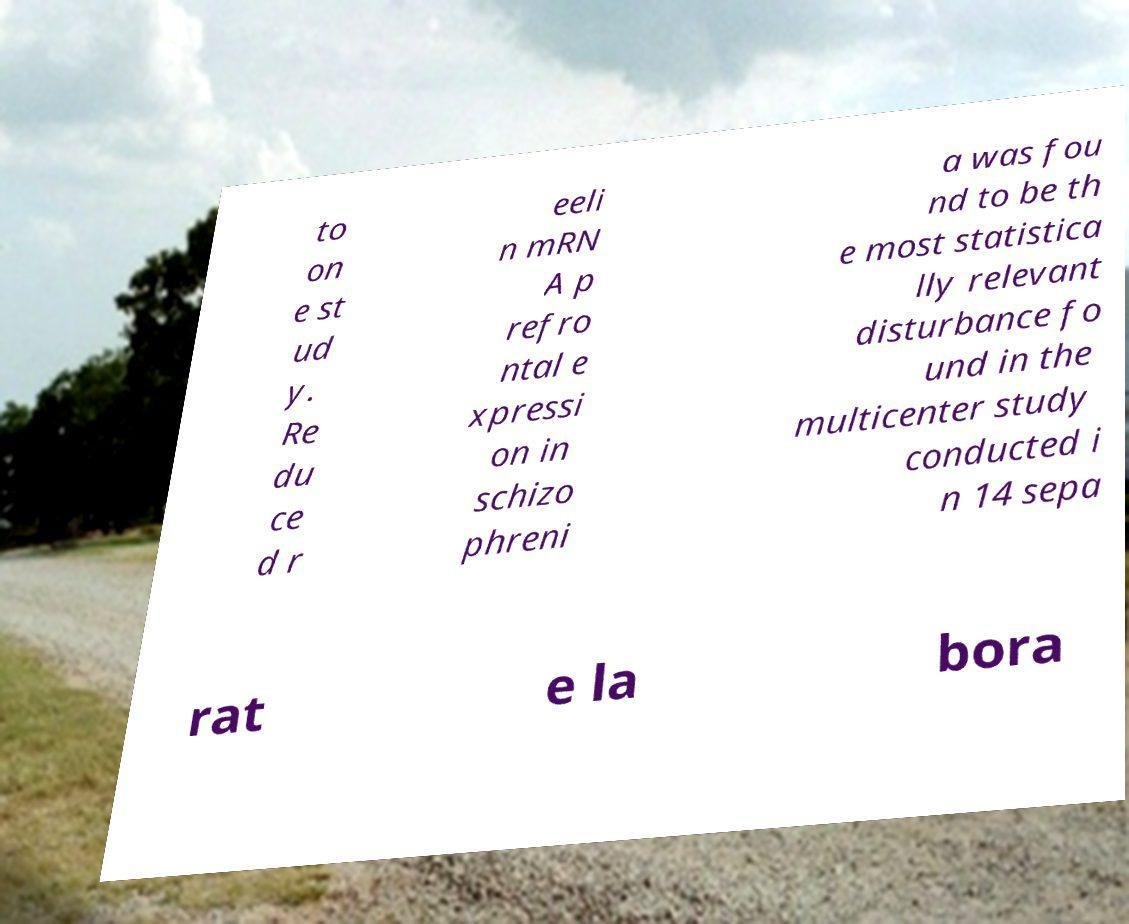What messages or text are displayed in this image? I need them in a readable, typed format. to on e st ud y. Re du ce d r eeli n mRN A p refro ntal e xpressi on in schizo phreni a was fou nd to be th e most statistica lly relevant disturbance fo und in the multicenter study conducted i n 14 sepa rat e la bora 